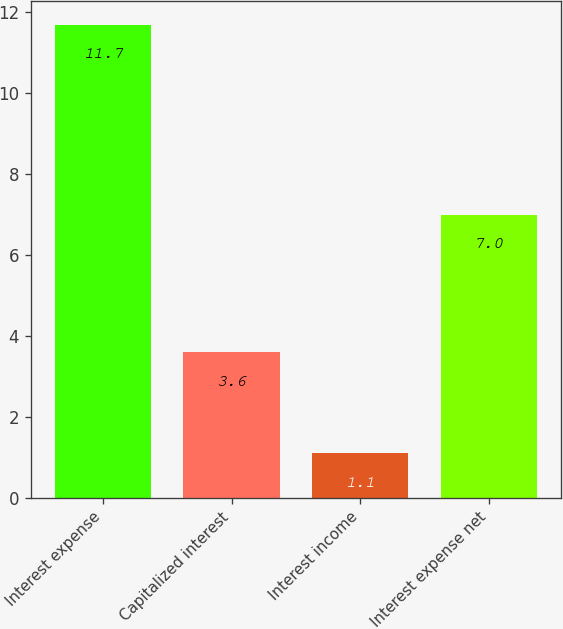Convert chart to OTSL. <chart><loc_0><loc_0><loc_500><loc_500><bar_chart><fcel>Interest expense<fcel>Capitalized interest<fcel>Interest income<fcel>Interest expense net<nl><fcel>11.7<fcel>3.6<fcel>1.1<fcel>7<nl></chart> 